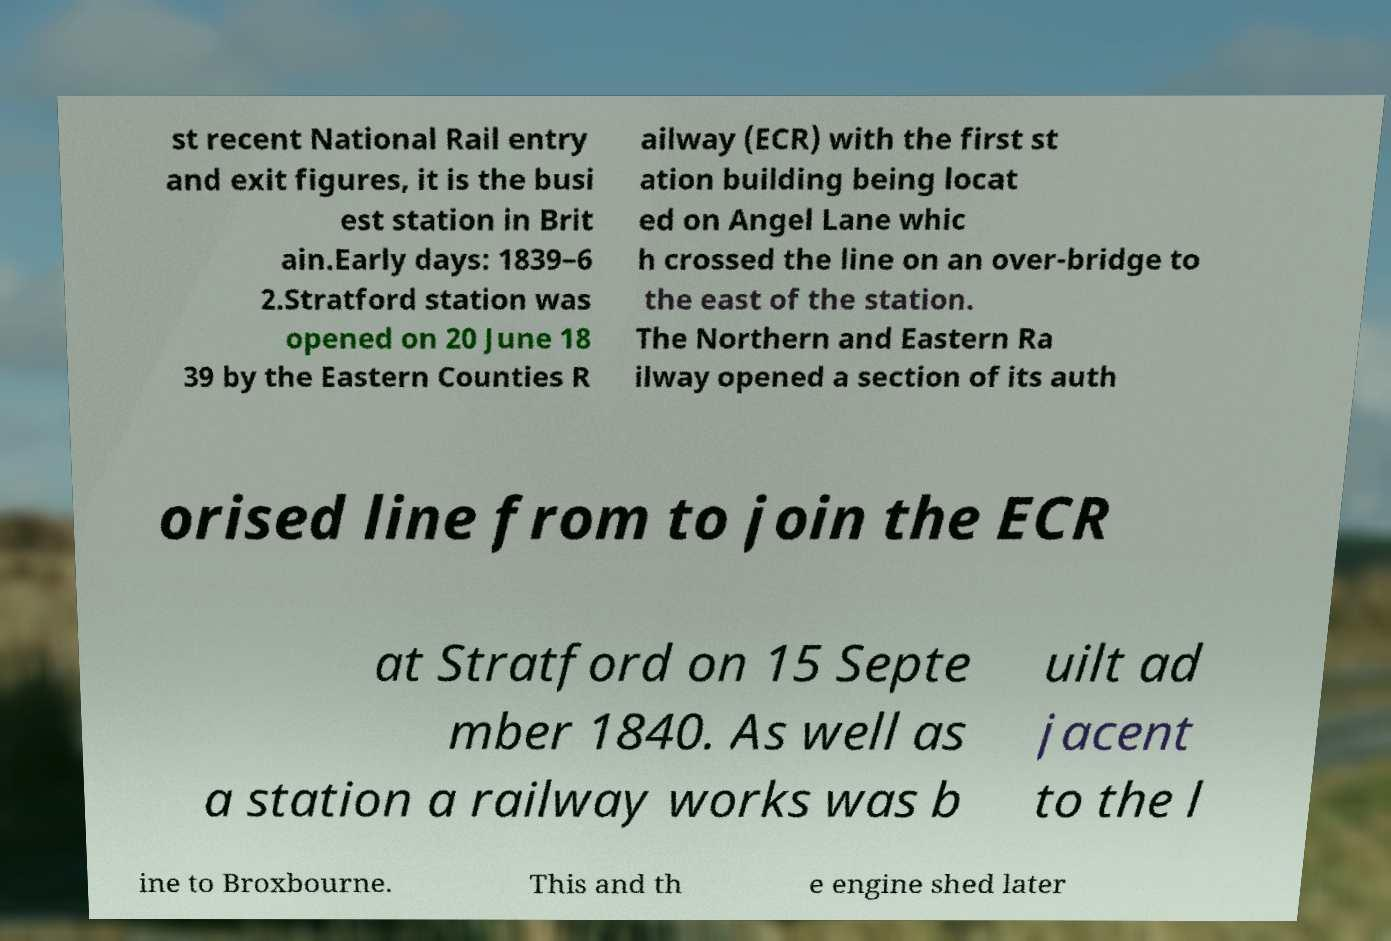Can you accurately transcribe the text from the provided image for me? st recent National Rail entry and exit figures, it is the busi est station in Brit ain.Early days: 1839–6 2.Stratford station was opened on 20 June 18 39 by the Eastern Counties R ailway (ECR) with the first st ation building being locat ed on Angel Lane whic h crossed the line on an over-bridge to the east of the station. The Northern and Eastern Ra ilway opened a section of its auth orised line from to join the ECR at Stratford on 15 Septe mber 1840. As well as a station a railway works was b uilt ad jacent to the l ine to Broxbourne. This and th e engine shed later 